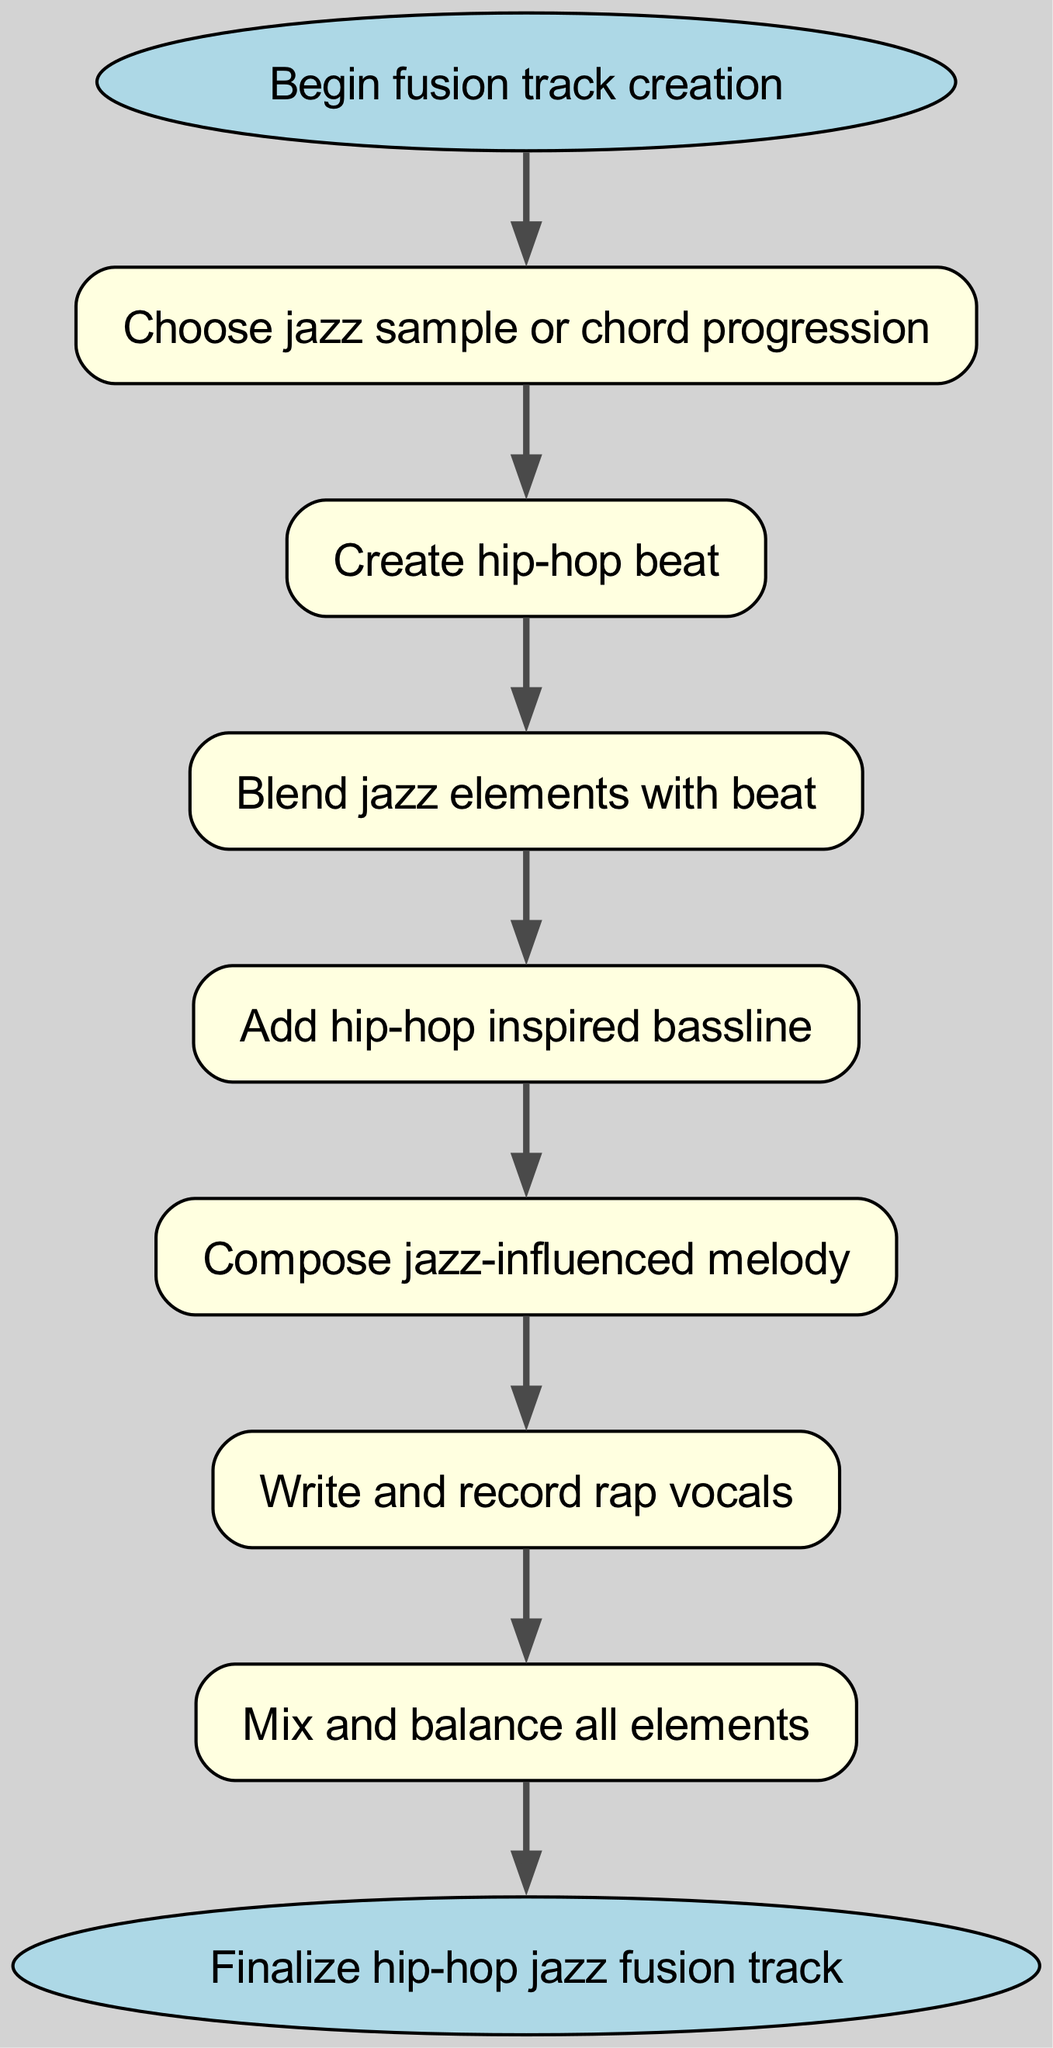What is the first step in the flowchart? The first step is represented by the "Begin fusion track creation" node, which serves as the starting point of the process outlined in the diagram.
Answer: Begin fusion track creation How many distinct steps are there in creating a hip-hop jazz fusion track? By counting the nodes in the diagram excluding the start and end nodes, there are six distinct steps (Choose jazz sample, Create hip-hop beat, etc.).
Answer: Six What follows after creating a hip-hop beat? The diagram indicates that "Blend jazz elements with beat" directly follows "Create hip-hop beat," showing the sequential flow of actions.
Answer: Blend jazz elements with beat What is the last action to complete the track creation? The final action in the diagram is indicated by the "Finalize hip-hop jazz fusion track" node, which signifies the completion of the process.
Answer: Finalize hip-hop jazz fusion track What type of melody is suggested in the process? The diagram specifies to "Compose jazz-influenced melody," indicating the type of melody to be created.
Answer: Jazz-influenced melody Which step directly precedes the mixing of elements? According to the flowchart, "Write and record rap vocals" is the step that comes directly before "Mix and balance all elements."
Answer: Write and record rap vocals What is the relationship between the "Add hip-hop inspired bassline" and "Compose jazz-influenced melody"? The relationship is sequential; the "Add hip-hop inspired bassline" step directly leads to the "Compose jazz-influenced melody" step in the flow of creation.
Answer: Sequential How many transitions connect the nodes in the flowchart? The flowchart depicts seven connections between nodes, representing the transitions from one action to the next throughout the creation process.
Answer: Seven 